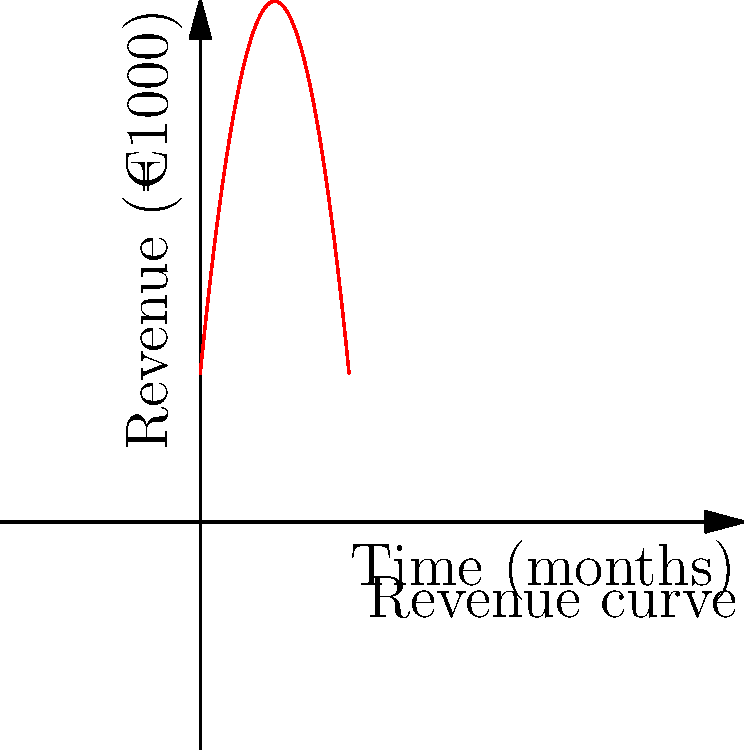An independent European cinema's revenue curve over time is represented by the quadratic function $R(t) = -0.5t^2 + 10t + 20$, where $R$ is the revenue in thousands of euros and $t$ is the time in months. At what month does the cinema reach its peak revenue, and what is this maximum revenue? To find the peak revenue and when it occurs, we need to follow these steps:

1. The revenue function is a quadratic equation in the form $f(x) = ax^2 + bx + c$, where:
   $a = -0.5$, $b = 10$, and $c = 20$

2. For a quadratic function, the x-coordinate of the vertex represents the point where the function reaches its maximum (if $a < 0$) or minimum (if $a > 0$).

3. The formula for the x-coordinate of the vertex is: $x = -\frac{b}{2a}$

4. Substituting our values:
   $t = -\frac{10}{2(-0.5)} = -\frac{10}{-1} = 10$ months

5. To find the maximum revenue, we substitute this t-value back into the original function:
   $R(10) = -0.5(10)^2 + 10(10) + 20$
   $= -0.5(100) + 100 + 20$
   $= -50 + 100 + 20$
   $= 70$ thousand euros

Therefore, the cinema reaches its peak revenue after 10 months, and the maximum revenue is €70,000.
Answer: 10 months; €70,000 